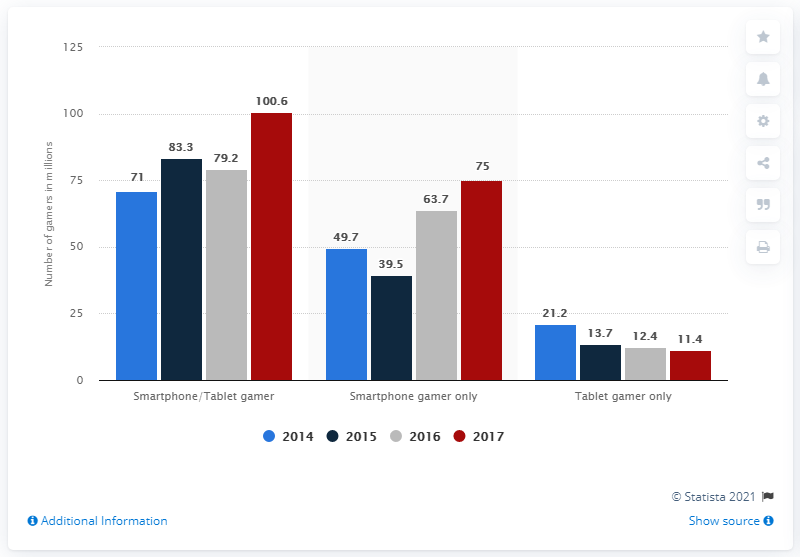Outline some significant characteristics in this image. In 2017, an estimated 75 million smartphone gamers resided in North America. 